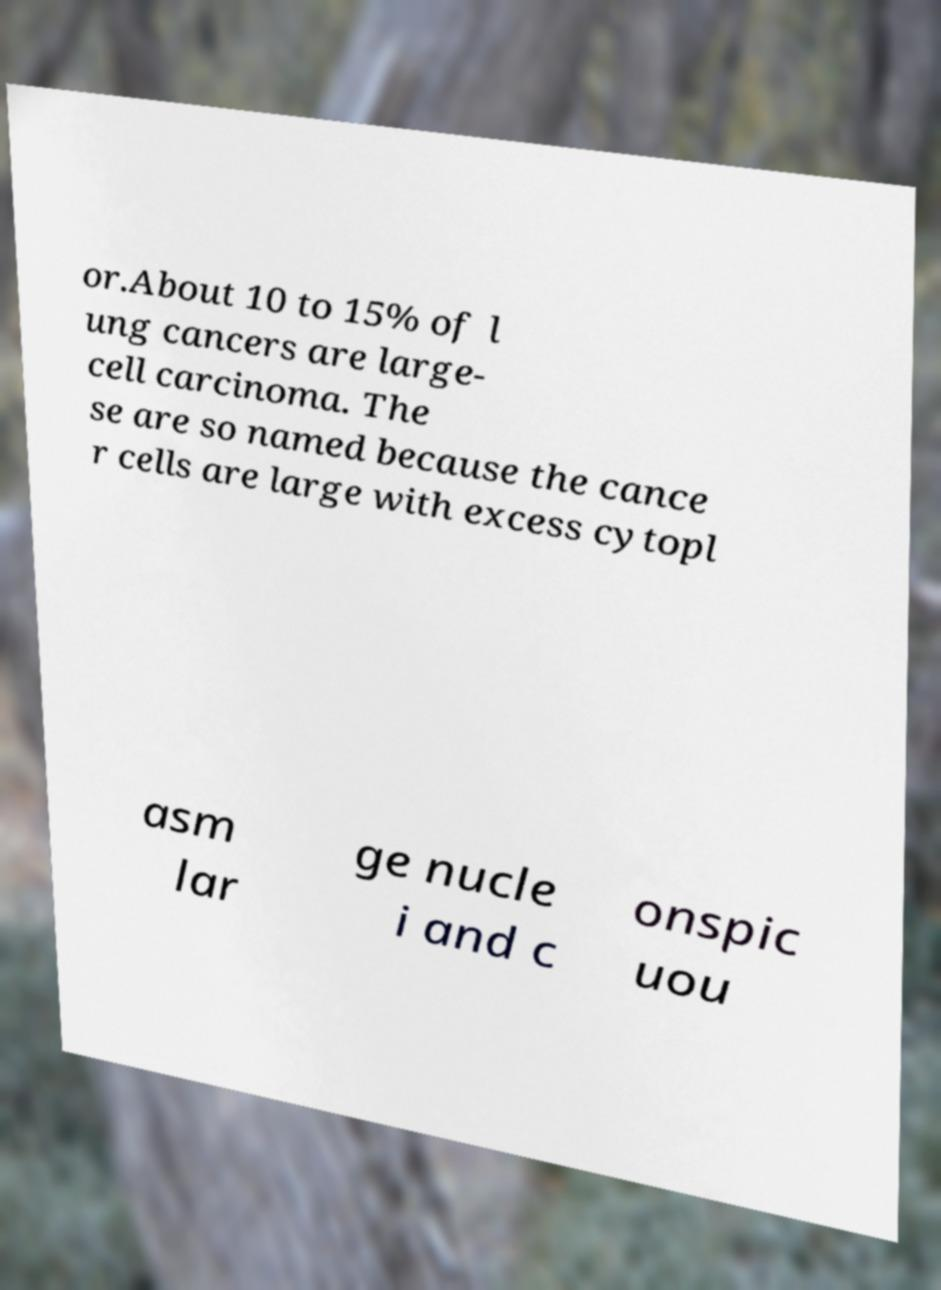Can you accurately transcribe the text from the provided image for me? or.About 10 to 15% of l ung cancers are large- cell carcinoma. The se are so named because the cance r cells are large with excess cytopl asm lar ge nucle i and c onspic uou 